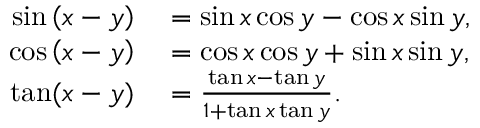<formula> <loc_0><loc_0><loc_500><loc_500>\begin{array} { r l } { \sin \left ( x - y \right ) } & = \sin x \cos y - \cos x \sin y , } \\ { \cos \left ( x - y \right ) } & = \cos x \cos y + \sin x \sin y , } \\ { \tan ( x - y ) } & = { \frac { \tan x - \tan y } { 1 + \tan x \tan y } } . } \end{array}</formula> 